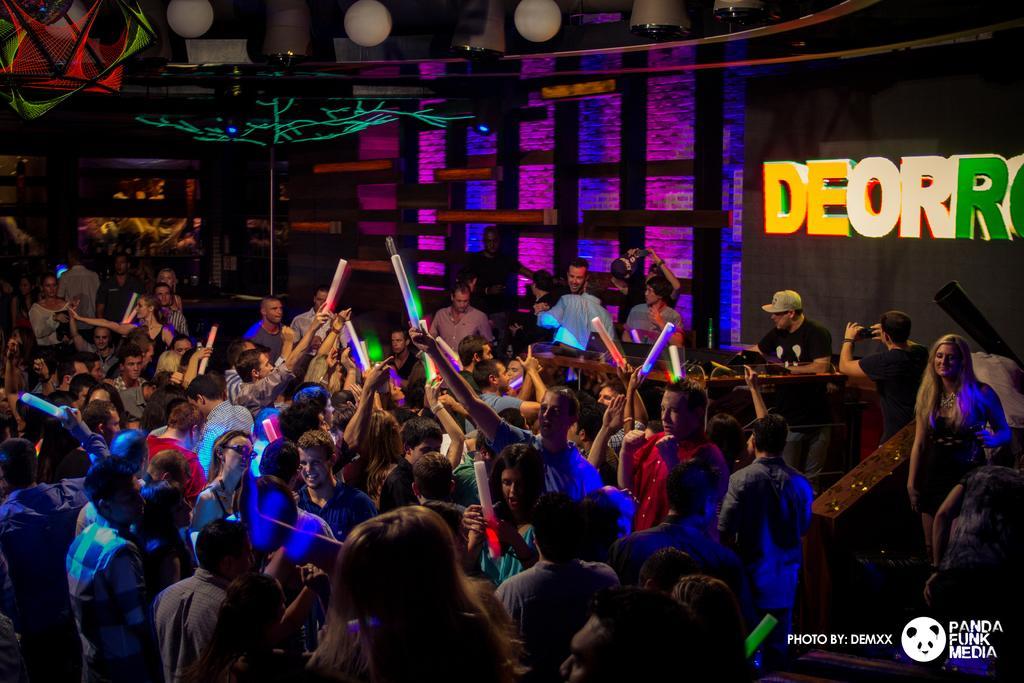Describe this image in one or two sentences. In the picture we can see some people are in one place and they are holding objects in their hands, among them one person is operating music system, behind we can see a board to the wall. 